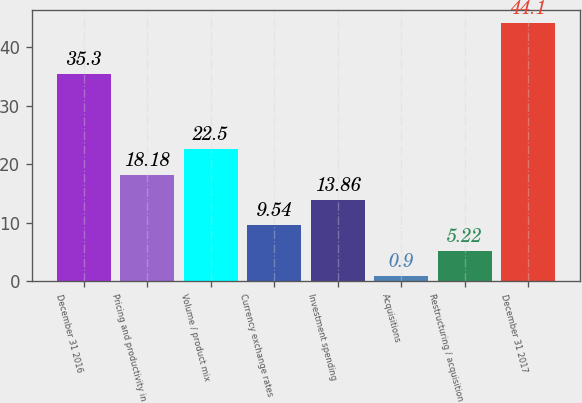<chart> <loc_0><loc_0><loc_500><loc_500><bar_chart><fcel>December 31 2016<fcel>Pricing and productivity in<fcel>Volume / product mix<fcel>Currency exchange rates<fcel>Investment spending<fcel>Acquisitions<fcel>Restructuring / acquisition<fcel>December 31 2017<nl><fcel>35.3<fcel>18.18<fcel>22.5<fcel>9.54<fcel>13.86<fcel>0.9<fcel>5.22<fcel>44.1<nl></chart> 